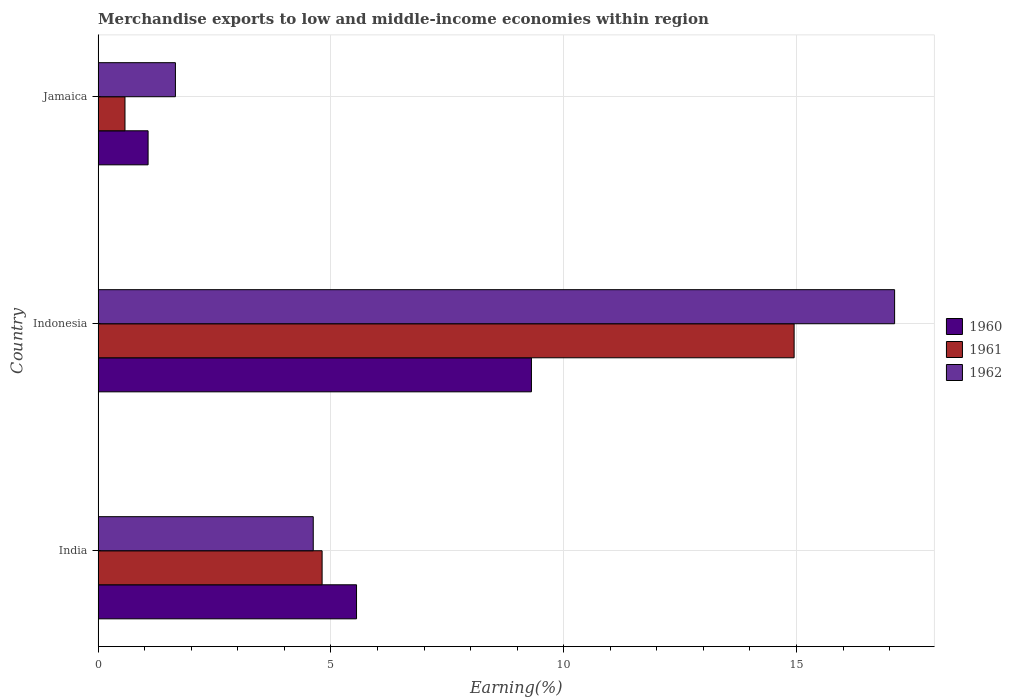How many different coloured bars are there?
Your answer should be compact. 3. How many bars are there on the 3rd tick from the top?
Provide a succinct answer. 3. How many bars are there on the 2nd tick from the bottom?
Your response must be concise. 3. What is the percentage of amount earned from merchandise exports in 1960 in Jamaica?
Keep it short and to the point. 1.07. Across all countries, what is the maximum percentage of amount earned from merchandise exports in 1962?
Your answer should be compact. 17.11. Across all countries, what is the minimum percentage of amount earned from merchandise exports in 1962?
Your answer should be compact. 1.66. In which country was the percentage of amount earned from merchandise exports in 1961 maximum?
Your answer should be very brief. Indonesia. In which country was the percentage of amount earned from merchandise exports in 1962 minimum?
Keep it short and to the point. Jamaica. What is the total percentage of amount earned from merchandise exports in 1960 in the graph?
Make the answer very short. 15.93. What is the difference between the percentage of amount earned from merchandise exports in 1960 in India and that in Jamaica?
Ensure brevity in your answer.  4.48. What is the difference between the percentage of amount earned from merchandise exports in 1960 in Jamaica and the percentage of amount earned from merchandise exports in 1962 in Indonesia?
Ensure brevity in your answer.  -16.03. What is the average percentage of amount earned from merchandise exports in 1962 per country?
Provide a succinct answer. 7.8. What is the difference between the percentage of amount earned from merchandise exports in 1961 and percentage of amount earned from merchandise exports in 1962 in Indonesia?
Your answer should be compact. -2.16. In how many countries, is the percentage of amount earned from merchandise exports in 1961 greater than 8 %?
Provide a succinct answer. 1. What is the ratio of the percentage of amount earned from merchandise exports in 1962 in India to that in Indonesia?
Your answer should be very brief. 0.27. Is the difference between the percentage of amount earned from merchandise exports in 1961 in India and Jamaica greater than the difference between the percentage of amount earned from merchandise exports in 1962 in India and Jamaica?
Make the answer very short. Yes. What is the difference between the highest and the second highest percentage of amount earned from merchandise exports in 1961?
Keep it short and to the point. 10.14. What is the difference between the highest and the lowest percentage of amount earned from merchandise exports in 1961?
Keep it short and to the point. 14.37. In how many countries, is the percentage of amount earned from merchandise exports in 1961 greater than the average percentage of amount earned from merchandise exports in 1961 taken over all countries?
Make the answer very short. 1. Does the graph contain grids?
Make the answer very short. Yes. Where does the legend appear in the graph?
Offer a terse response. Center right. How many legend labels are there?
Ensure brevity in your answer.  3. What is the title of the graph?
Give a very brief answer. Merchandise exports to low and middle-income economies within region. What is the label or title of the X-axis?
Offer a very short reply. Earning(%). What is the Earning(%) of 1960 in India?
Make the answer very short. 5.55. What is the Earning(%) in 1961 in India?
Provide a short and direct response. 4.81. What is the Earning(%) in 1962 in India?
Make the answer very short. 4.62. What is the Earning(%) of 1960 in Indonesia?
Offer a terse response. 9.31. What is the Earning(%) of 1961 in Indonesia?
Your response must be concise. 14.95. What is the Earning(%) of 1962 in Indonesia?
Provide a succinct answer. 17.11. What is the Earning(%) in 1960 in Jamaica?
Provide a short and direct response. 1.07. What is the Earning(%) of 1961 in Jamaica?
Give a very brief answer. 0.58. What is the Earning(%) in 1962 in Jamaica?
Provide a succinct answer. 1.66. Across all countries, what is the maximum Earning(%) in 1960?
Provide a succinct answer. 9.31. Across all countries, what is the maximum Earning(%) in 1961?
Offer a terse response. 14.95. Across all countries, what is the maximum Earning(%) of 1962?
Provide a succinct answer. 17.11. Across all countries, what is the minimum Earning(%) of 1960?
Give a very brief answer. 1.07. Across all countries, what is the minimum Earning(%) of 1961?
Offer a terse response. 0.58. Across all countries, what is the minimum Earning(%) in 1962?
Give a very brief answer. 1.66. What is the total Earning(%) in 1960 in the graph?
Your response must be concise. 15.93. What is the total Earning(%) of 1961 in the graph?
Provide a short and direct response. 20.34. What is the total Earning(%) of 1962 in the graph?
Keep it short and to the point. 23.39. What is the difference between the Earning(%) of 1960 in India and that in Indonesia?
Offer a very short reply. -3.76. What is the difference between the Earning(%) in 1961 in India and that in Indonesia?
Your response must be concise. -10.14. What is the difference between the Earning(%) in 1962 in India and that in Indonesia?
Provide a succinct answer. -12.49. What is the difference between the Earning(%) in 1960 in India and that in Jamaica?
Offer a terse response. 4.48. What is the difference between the Earning(%) in 1961 in India and that in Jamaica?
Your answer should be very brief. 4.23. What is the difference between the Earning(%) of 1962 in India and that in Jamaica?
Your response must be concise. 2.96. What is the difference between the Earning(%) in 1960 in Indonesia and that in Jamaica?
Make the answer very short. 8.23. What is the difference between the Earning(%) of 1961 in Indonesia and that in Jamaica?
Your response must be concise. 14.37. What is the difference between the Earning(%) of 1962 in Indonesia and that in Jamaica?
Your response must be concise. 15.45. What is the difference between the Earning(%) of 1960 in India and the Earning(%) of 1961 in Indonesia?
Give a very brief answer. -9.4. What is the difference between the Earning(%) of 1960 in India and the Earning(%) of 1962 in Indonesia?
Your answer should be very brief. -11.56. What is the difference between the Earning(%) of 1961 in India and the Earning(%) of 1962 in Indonesia?
Offer a very short reply. -12.3. What is the difference between the Earning(%) of 1960 in India and the Earning(%) of 1961 in Jamaica?
Make the answer very short. 4.97. What is the difference between the Earning(%) in 1960 in India and the Earning(%) in 1962 in Jamaica?
Your answer should be very brief. 3.89. What is the difference between the Earning(%) of 1961 in India and the Earning(%) of 1962 in Jamaica?
Ensure brevity in your answer.  3.15. What is the difference between the Earning(%) of 1960 in Indonesia and the Earning(%) of 1961 in Jamaica?
Provide a succinct answer. 8.73. What is the difference between the Earning(%) in 1960 in Indonesia and the Earning(%) in 1962 in Jamaica?
Provide a succinct answer. 7.65. What is the difference between the Earning(%) in 1961 in Indonesia and the Earning(%) in 1962 in Jamaica?
Your response must be concise. 13.29. What is the average Earning(%) of 1960 per country?
Your response must be concise. 5.31. What is the average Earning(%) in 1961 per country?
Your response must be concise. 6.78. What is the average Earning(%) of 1962 per country?
Provide a short and direct response. 7.8. What is the difference between the Earning(%) of 1960 and Earning(%) of 1961 in India?
Provide a short and direct response. 0.74. What is the difference between the Earning(%) in 1960 and Earning(%) in 1962 in India?
Give a very brief answer. 0.93. What is the difference between the Earning(%) of 1961 and Earning(%) of 1962 in India?
Offer a terse response. 0.19. What is the difference between the Earning(%) in 1960 and Earning(%) in 1961 in Indonesia?
Offer a very short reply. -5.64. What is the difference between the Earning(%) of 1960 and Earning(%) of 1962 in Indonesia?
Provide a succinct answer. -7.8. What is the difference between the Earning(%) of 1961 and Earning(%) of 1962 in Indonesia?
Your response must be concise. -2.16. What is the difference between the Earning(%) of 1960 and Earning(%) of 1961 in Jamaica?
Ensure brevity in your answer.  0.5. What is the difference between the Earning(%) in 1960 and Earning(%) in 1962 in Jamaica?
Offer a terse response. -0.59. What is the difference between the Earning(%) of 1961 and Earning(%) of 1962 in Jamaica?
Your answer should be compact. -1.08. What is the ratio of the Earning(%) in 1960 in India to that in Indonesia?
Keep it short and to the point. 0.6. What is the ratio of the Earning(%) in 1961 in India to that in Indonesia?
Your answer should be very brief. 0.32. What is the ratio of the Earning(%) of 1962 in India to that in Indonesia?
Your response must be concise. 0.27. What is the ratio of the Earning(%) in 1960 in India to that in Jamaica?
Offer a terse response. 5.17. What is the ratio of the Earning(%) in 1961 in India to that in Jamaica?
Ensure brevity in your answer.  8.34. What is the ratio of the Earning(%) in 1962 in India to that in Jamaica?
Keep it short and to the point. 2.78. What is the ratio of the Earning(%) in 1960 in Indonesia to that in Jamaica?
Your answer should be compact. 8.67. What is the ratio of the Earning(%) of 1961 in Indonesia to that in Jamaica?
Your response must be concise. 25.91. What is the ratio of the Earning(%) of 1962 in Indonesia to that in Jamaica?
Provide a succinct answer. 10.3. What is the difference between the highest and the second highest Earning(%) in 1960?
Your answer should be very brief. 3.76. What is the difference between the highest and the second highest Earning(%) in 1961?
Offer a very short reply. 10.14. What is the difference between the highest and the second highest Earning(%) of 1962?
Give a very brief answer. 12.49. What is the difference between the highest and the lowest Earning(%) in 1960?
Offer a terse response. 8.23. What is the difference between the highest and the lowest Earning(%) of 1961?
Provide a succinct answer. 14.37. What is the difference between the highest and the lowest Earning(%) of 1962?
Ensure brevity in your answer.  15.45. 